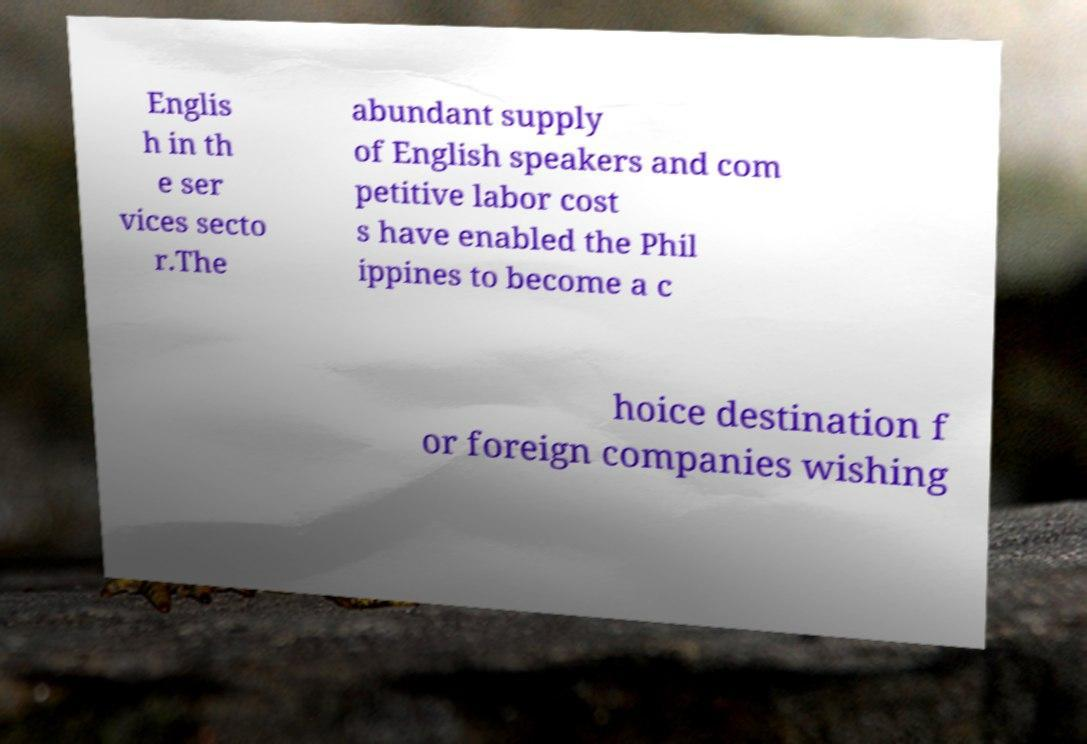Can you accurately transcribe the text from the provided image for me? Englis h in th e ser vices secto r.The abundant supply of English speakers and com petitive labor cost s have enabled the Phil ippines to become a c hoice destination f or foreign companies wishing 